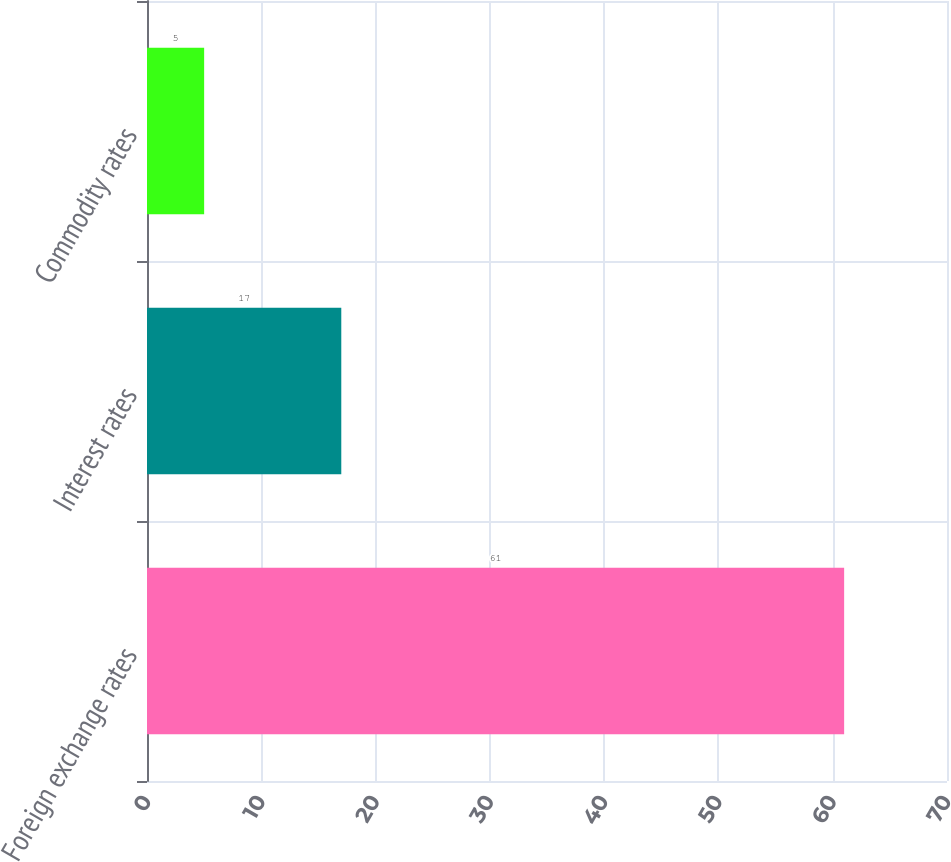<chart> <loc_0><loc_0><loc_500><loc_500><bar_chart><fcel>Foreign exchange rates<fcel>Interest rates<fcel>Commodity rates<nl><fcel>61<fcel>17<fcel>5<nl></chart> 